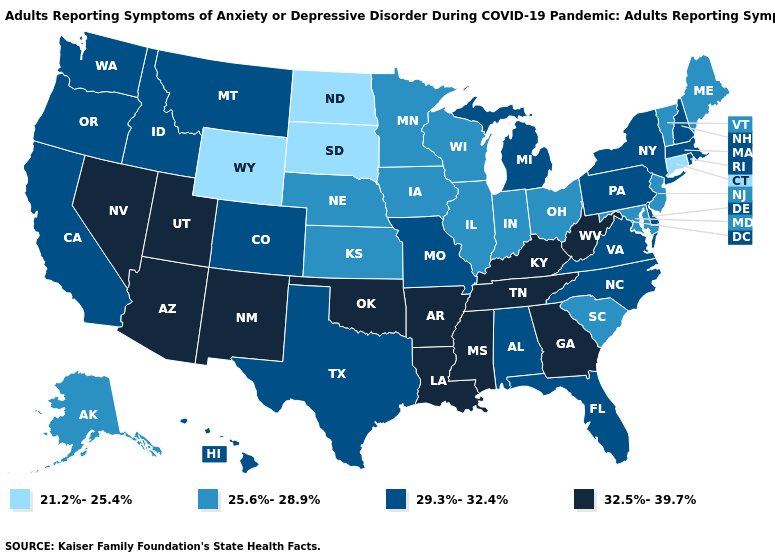Which states have the lowest value in the Northeast?
Give a very brief answer. Connecticut. Among the states that border Utah , which have the highest value?
Quick response, please. Arizona, Nevada, New Mexico. What is the highest value in states that border Alabama?
Keep it brief. 32.5%-39.7%. What is the value of Indiana?
Write a very short answer. 25.6%-28.9%. Does Alabama have a lower value than Georgia?
Keep it brief. Yes. Does Indiana have the lowest value in the MidWest?
Answer briefly. No. Name the states that have a value in the range 32.5%-39.7%?
Concise answer only. Arizona, Arkansas, Georgia, Kentucky, Louisiana, Mississippi, Nevada, New Mexico, Oklahoma, Tennessee, Utah, West Virginia. What is the lowest value in the South?
Short answer required. 25.6%-28.9%. How many symbols are there in the legend?
Answer briefly. 4. What is the lowest value in the South?
Concise answer only. 25.6%-28.9%. Does Minnesota have the highest value in the MidWest?
Keep it brief. No. What is the highest value in the South ?
Answer briefly. 32.5%-39.7%. What is the value of New Jersey?
Give a very brief answer. 25.6%-28.9%. Name the states that have a value in the range 25.6%-28.9%?
Write a very short answer. Alaska, Illinois, Indiana, Iowa, Kansas, Maine, Maryland, Minnesota, Nebraska, New Jersey, Ohio, South Carolina, Vermont, Wisconsin. What is the value of Montana?
Answer briefly. 29.3%-32.4%. 